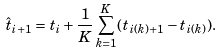<formula> <loc_0><loc_0><loc_500><loc_500>\hat { t } _ { i + 1 } = t _ { i } + \frac { 1 } { K } \sum _ { k = 1 } ^ { K } ( t _ { i ( k ) + 1 } - t _ { i ( k ) } ) .</formula> 